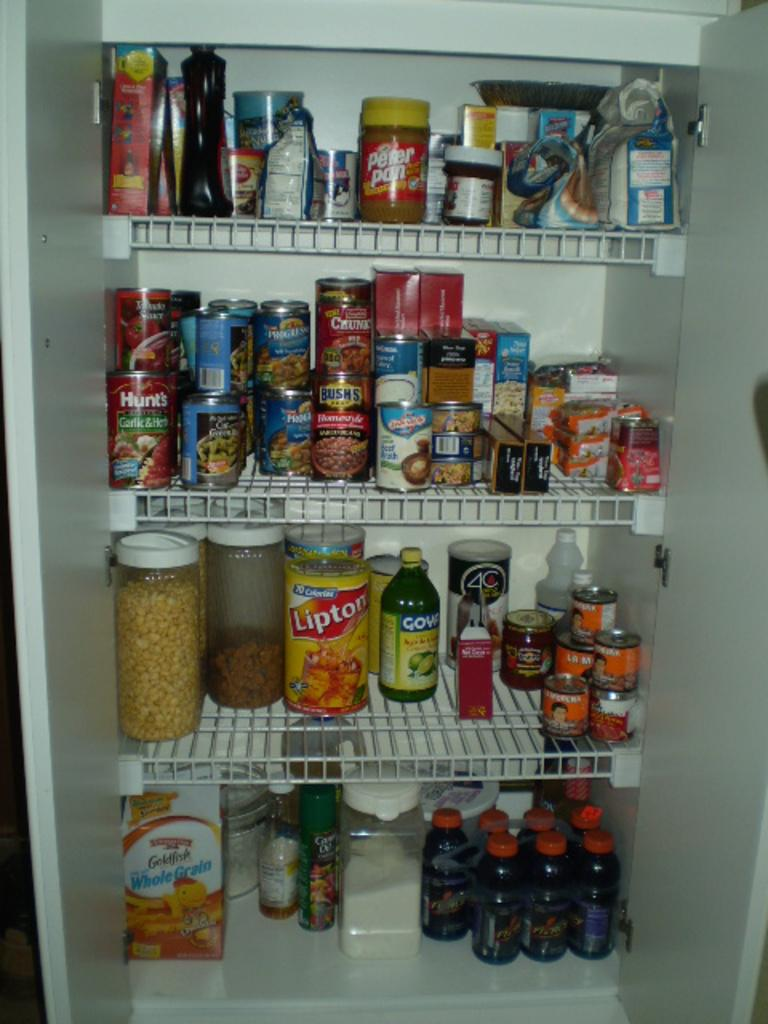<image>
Provide a brief description of the given image. a pantry filled with a variety of items including a box of whole grain goldfish in the bottom right 